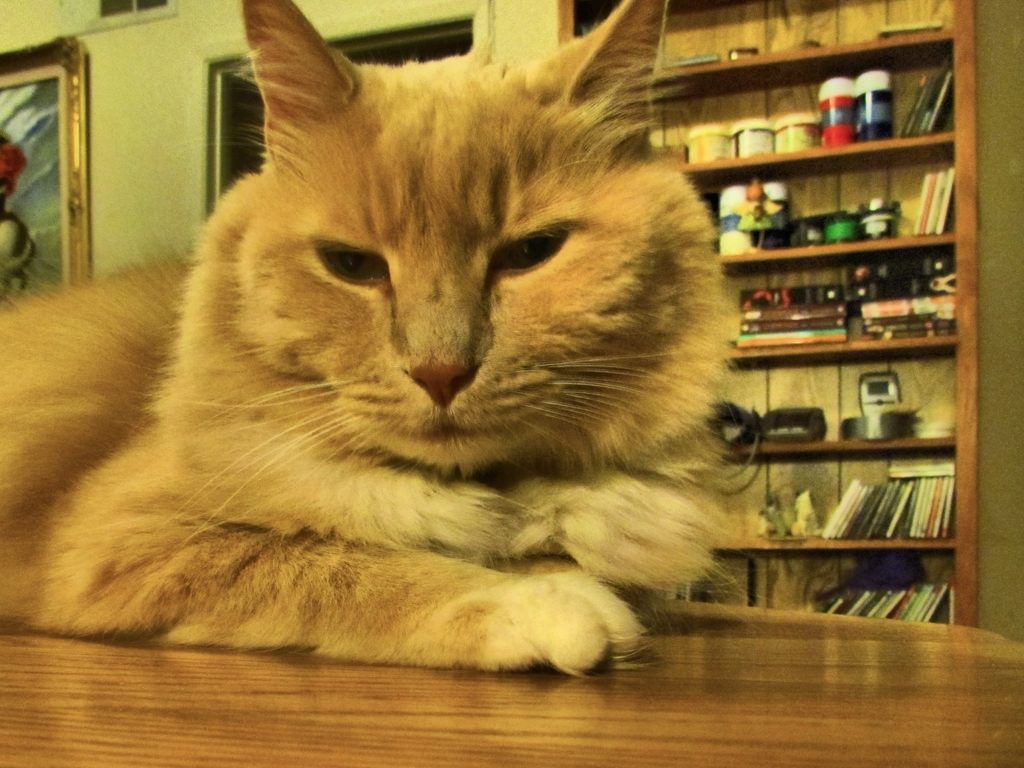Can you tell if the cat is currently in a relaxed or alert state? The cat's relaxed facial expression and calm body posture resting on the table suggest it is in a state of contentment or relaxation rather than alertness. Cats often demonstrate their comfort and trust when settling in visible, open areas of a home. 